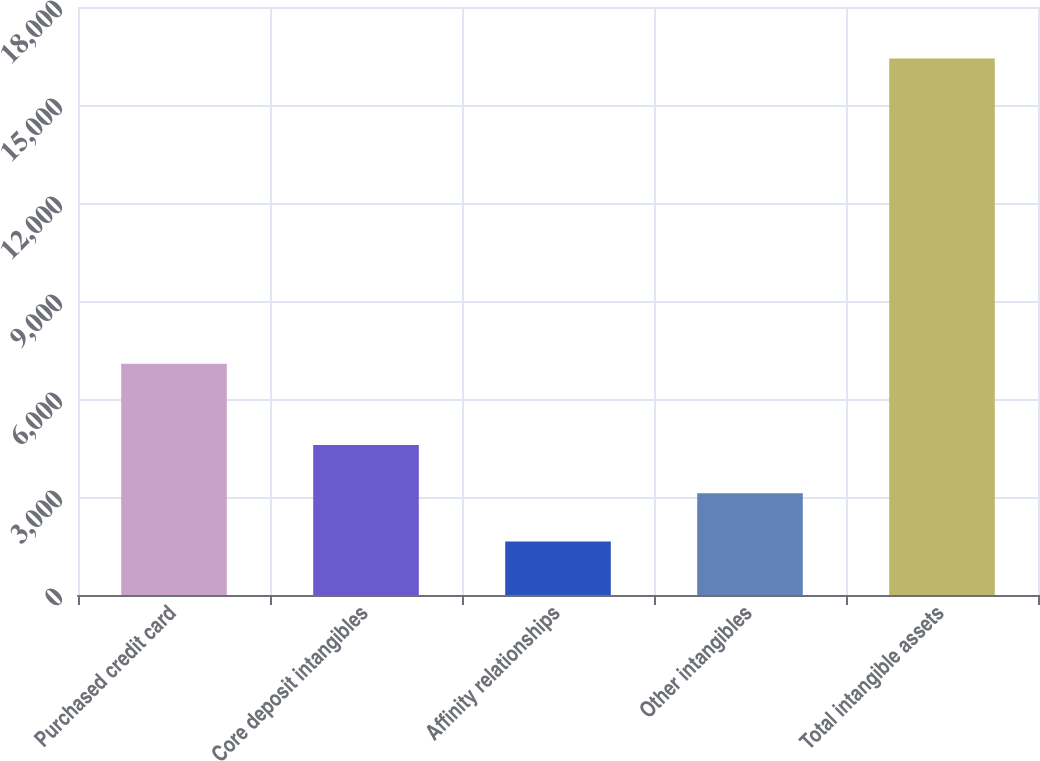Convert chart to OTSL. <chart><loc_0><loc_0><loc_500><loc_500><bar_chart><fcel>Purchased credit card<fcel>Core deposit intangibles<fcel>Affinity relationships<fcel>Other intangibles<fcel>Total intangible assets<nl><fcel>7080<fcel>4595.4<fcel>1638<fcel>3116.7<fcel>16425<nl></chart> 